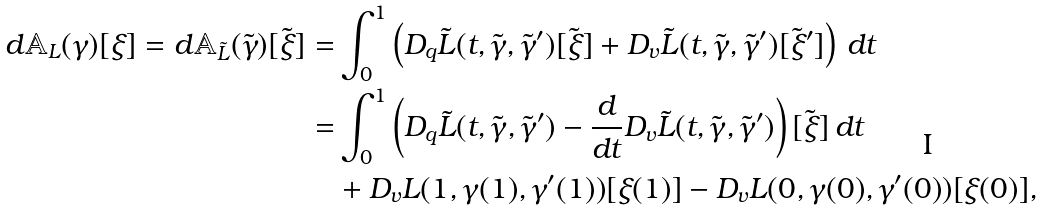Convert formula to latex. <formula><loc_0><loc_0><loc_500><loc_500>d \mathbb { A } _ { L } ( \gamma ) [ \xi ] = d \mathbb { A } _ { \tilde { L } } ( \tilde { \gamma } ) [ \tilde { \xi } ] = & \int _ { 0 } ^ { 1 } \left ( D _ { q } \tilde { L } ( t , \tilde { \gamma } , \tilde { \gamma } ^ { \prime } ) [ \tilde { \xi } ] + D _ { v } \tilde { L } ( t , \tilde { \gamma } , \tilde { \gamma } ^ { \prime } ) [ \tilde { \xi } ^ { \prime } ] \right ) \, d t \\ = & \int _ { 0 } ^ { 1 } \left ( D _ { q } \tilde { L } ( t , \tilde { \gamma } , \tilde { \gamma } ^ { \prime } ) - \frac { d } { d t } D _ { v } \tilde { L } ( t , \tilde { \gamma } , \tilde { \gamma } ^ { \prime } ) \right ) [ \tilde { \xi } ] \, d t \\ & + D _ { v } L ( 1 , \gamma ( 1 ) , \gamma ^ { \prime } ( 1 ) ) [ \xi ( 1 ) ] - D _ { v } L ( 0 , \gamma ( 0 ) , \gamma ^ { \prime } ( 0 ) ) [ \xi ( 0 ) ] ,</formula> 